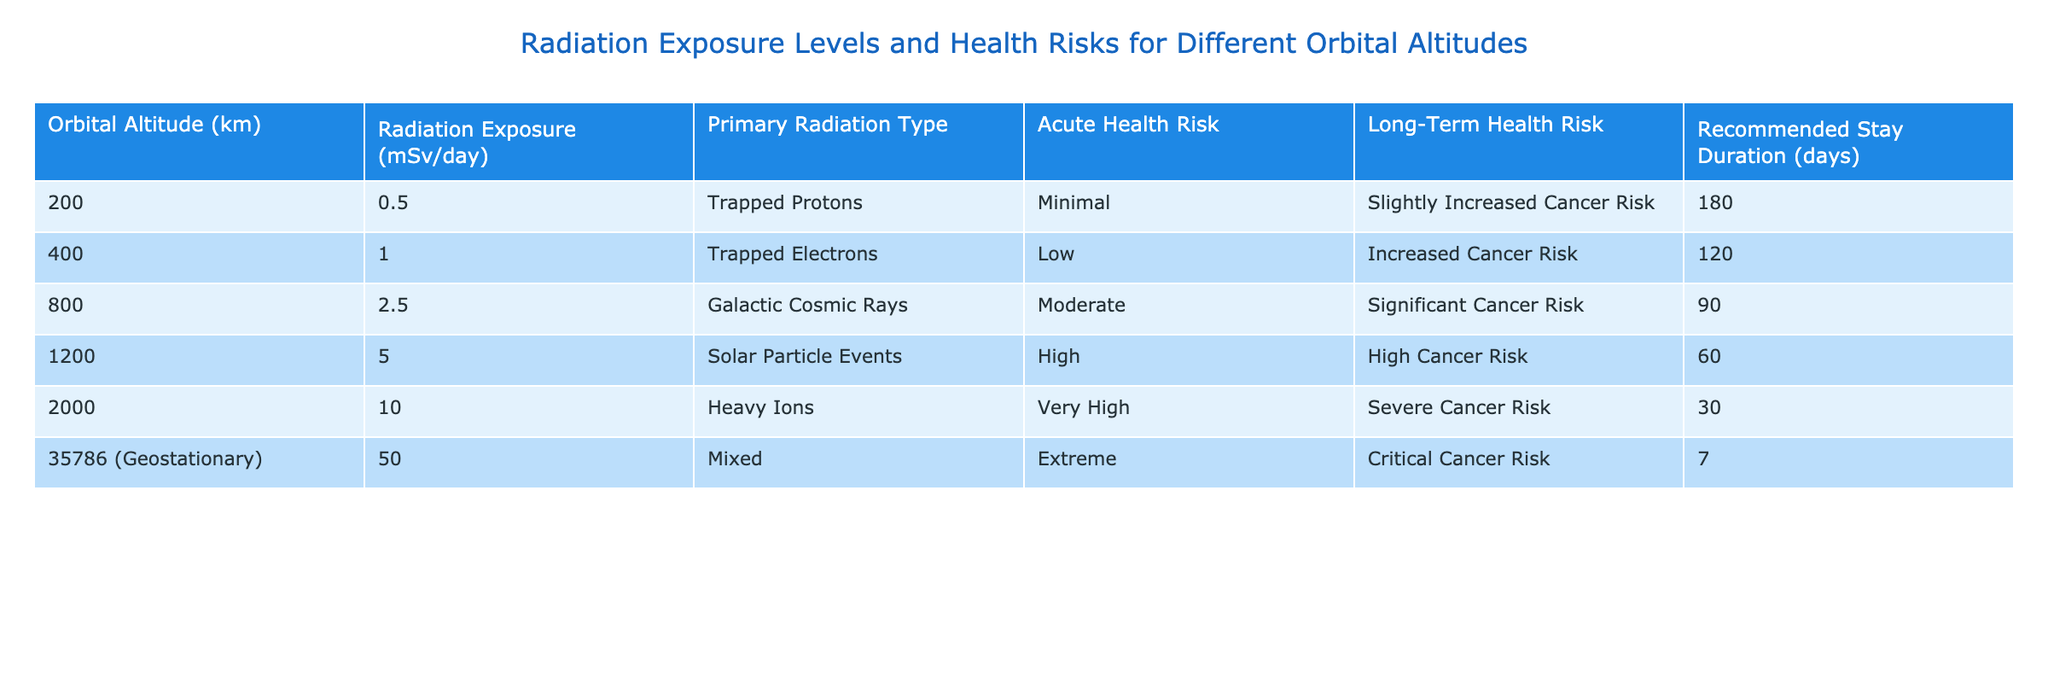What is the radiation exposure level at 400 km altitude? The table indicates that the radiation exposure level at an altitude of 400 km is 1.0 mSv/day.
Answer: 1.0 mSv/day Which orbital altitude has the highest radiation exposure? By examining the table, it's clear that the altitude of 35786 km has the highest radiation exposure at 50.0 mSv/day.
Answer: 35786 km What is the acute health risk associated with a stay at 1200 km? Looking at the table, the acute health risk associated with a stay at 1200 km is classified as High.
Answer: High What is the difference in radiation exposure between 200 km and 800 km? At 200 km, the exposure is 0.5 mSv/day, and at 800 km, it is 2.5 mSv/day. The difference is 2.5 - 0.5 = 2.0 mSv/day.
Answer: 2.0 mSv/day At which altitude is the recommended stay duration the shortest? The table shows that the recommended stay duration is the shortest at 35786 km, lasting only 7 days.
Answer: 35786 km Is the long-term health risk at 2000 km classified as Severe? Checking the table for the long-term health risk at 2000 km, it is indeed classified as Severe, thus the answer is true.
Answer: Yes What is the average radiation exposure for altitudes of 400 km, 800 km, and 1200 km? The radiation exposures are 1.0, 2.5, and 5.0 mSv/day respectively. The average is (1.0 + 2.5 + 5.0) / 3 = 2.5 mSv/day.
Answer: 2.5 mSv/day If a mission includes staying at 2000 km for the recommended duration, what would be the total radiation exposure? The stay is recommended for 30 days at a radiation exposure of 10.0 mSv/day. Thus, the total exposure is 10.0 * 30 = 300.0 mSv.
Answer: 300.0 mSv What types of primary radiation are found at the different altitudes? The table lists the following types: 200 km - Trapped Protons, 400 km - Trapped Electrons, 800 km - Galactic Cosmic Rays, 1200 km - Solar Particle Events, 2000 km - Heavy Ions, and 35786 km - Mixed.
Answer: Multiple types including Trapped Protons, Trapped Electrons, etc Which orbital altitude corresponds to a Moderate acute health risk? The table indicates that the 800 km altitude corresponds to a Moderate acute health risk.
Answer: 800 km 